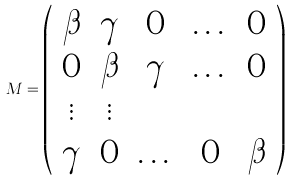<formula> <loc_0><loc_0><loc_500><loc_500>M = \left ( \begin{array} { c c c c c } \beta & \gamma & 0 & \dots & 0 \\ 0 & \beta & \gamma & \dots & 0 \\ \vdots & \vdots & & & \\ \gamma & 0 & \dots & 0 & \beta \end{array} \right )</formula> 